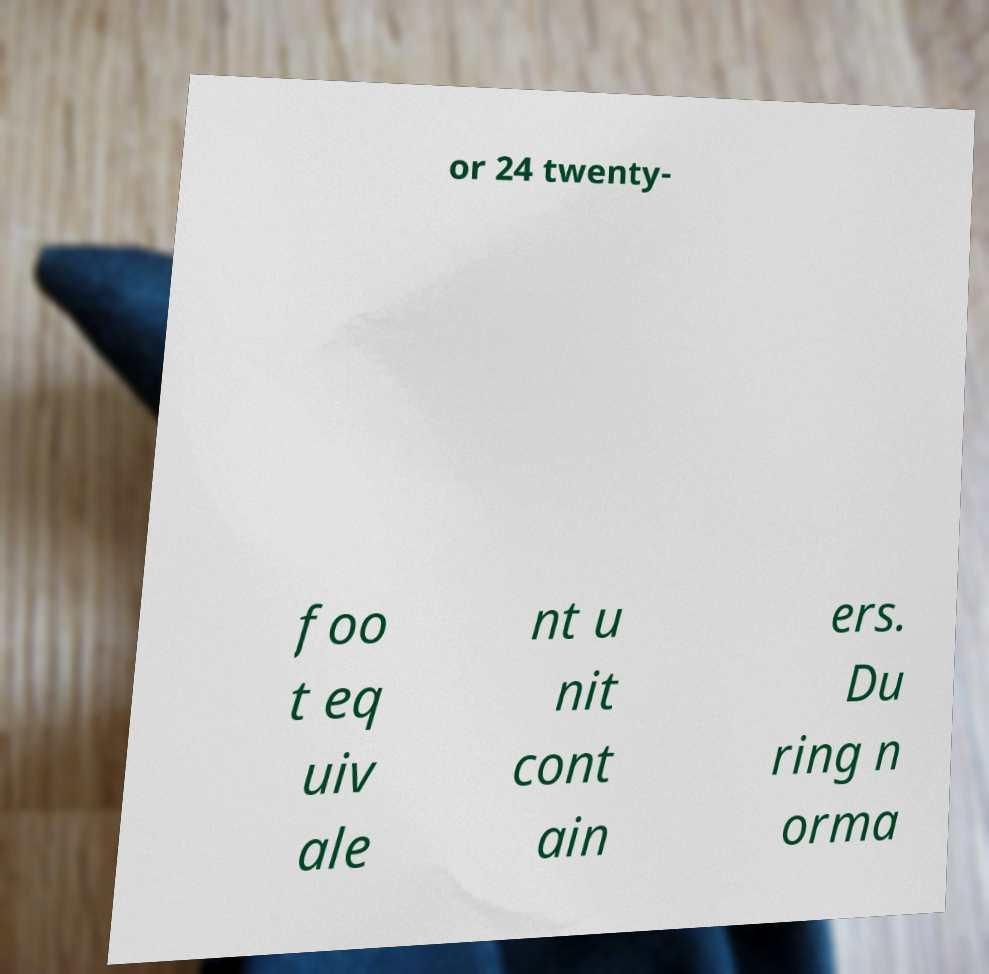There's text embedded in this image that I need extracted. Can you transcribe it verbatim? or 24 twenty- foo t eq uiv ale nt u nit cont ain ers. Du ring n orma 